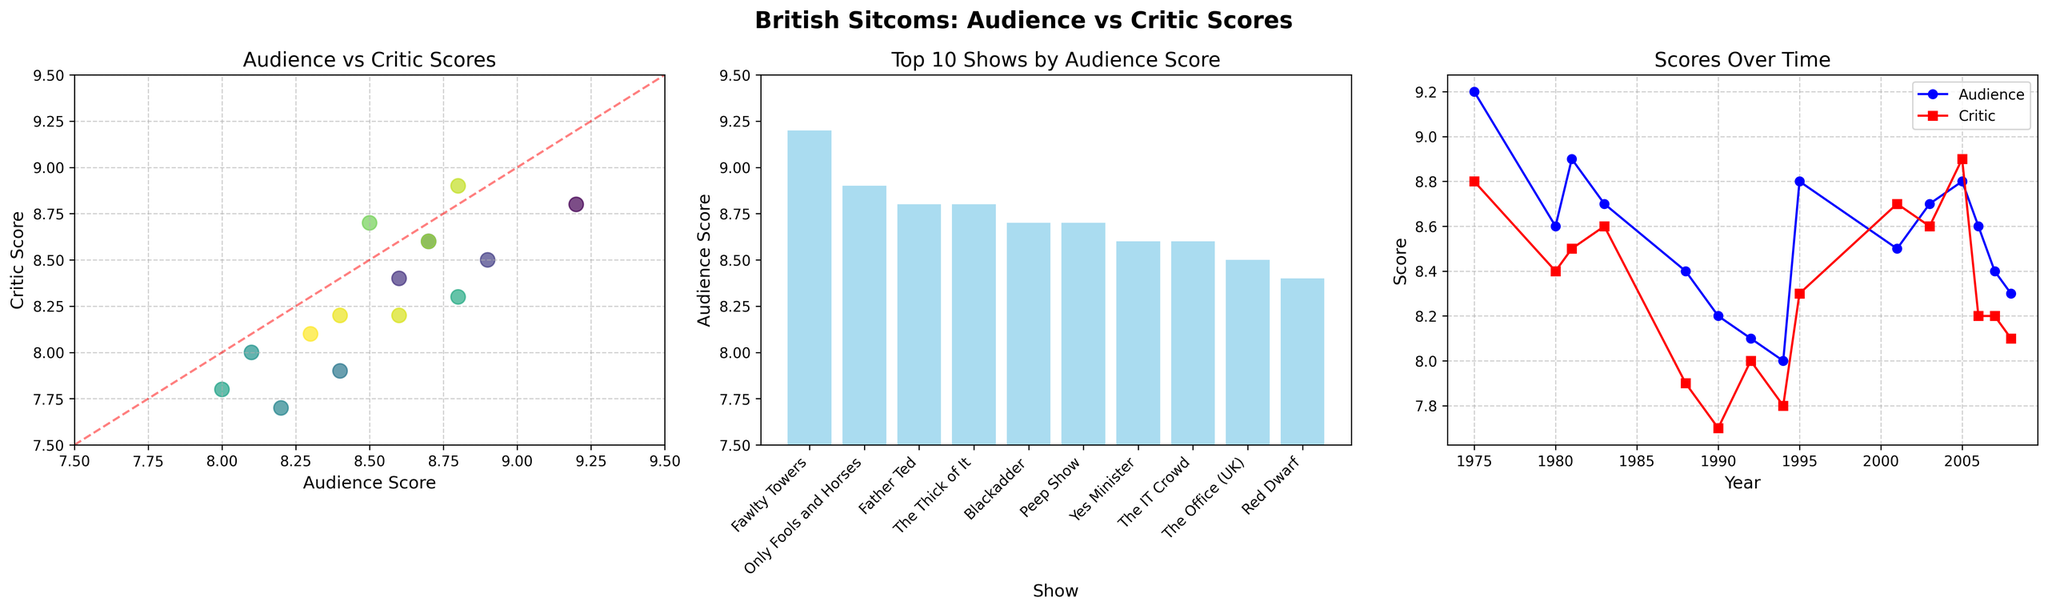What show has the highest audience score? By examining the bar chart titled "Top 10 Shows by Audience Score," we can see that "Fawlty Towers" has the tallest bar, indicating the highest audience score.
Answer: "Fawlty Towers" What is the audience score of "The Office (UK)"? Looking at the scatter plot, find the point labeled 2001 for "The Office (UK)" and observe the x-axis value for audience score. It is around 8.5.
Answer: 8.5 Which show has the biggest difference between audience and critic scores? By comparing the differences between the x and y values of each point in the scatter plot, "Father Ted" shows the largest gap, with audience score at 8.8 and critic score at 8.3, resulting in a difference of 0.5.
Answer: "Father Ted" Between which years does the line plot show a significant increase in critic scores? Observing the red line in the line plot, a significant increase in critic score occurs between 2004 and 2005.
Answer: 2004 to 2005 Which plot shows that audience and critics agreed the most on scores? The scatter plot has a diagonal line indicating agreement; the closest point to this line represents the highest agreement, which is "The Thick of It" in 2005.
Answer: Scatter plot, "The Thick of It" Which show is ranked 10th in terms of audience score and what is its score? By examining the bar chart, the 10th show by audience score is "The Vicar of Dibley," with an audience score of 8.0.
Answer: "The Vicar of Dibley", 8.0 Are there any shows where critics scored higher than the audience? Referring to the scatter plot, "The Office (UK)" has a critic score higher than the audience score.
Answer: Yes, "The Office (UK)" What’s the trend of audience scores over time? Observing the blue line in the line plot from 1975 to 2008, audience scores seem to fluctuate without a clear upward or downward trend.
Answer: Fluctuating What’s the average audience score among the top 10 shows by audience score? Looking at the top 10 shows in the bar plot and adding their scores: (9.2 + 8.9 + 8.8 + 8.7 + 8.7 + 8.6 + 8.6 + 8.6 + 8.4 + 8.3) = 84.8, the average is 84.8 / 10 = 8.48.
Answer: 8.48 Which show witnessed the highest critic score and what year was it released? The scatter plot shows the highest critic score is "The Thick of It," with a score of 8.9, released in 2005.
Answer: "The Thick of It", 2005 